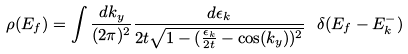<formula> <loc_0><loc_0><loc_500><loc_500>\rho ( E _ { f } ) = \int \frac { d k _ { y } } { ( 2 \pi ) ^ { 2 } } \frac { d \epsilon _ { k } } { 2 t \sqrt { 1 - ( \frac { \epsilon _ { k } } { 2 t } - \cos ( k _ { y } ) ) ^ { 2 } } } \ \delta ( E _ { f } - E ^ { - } _ { k } )</formula> 